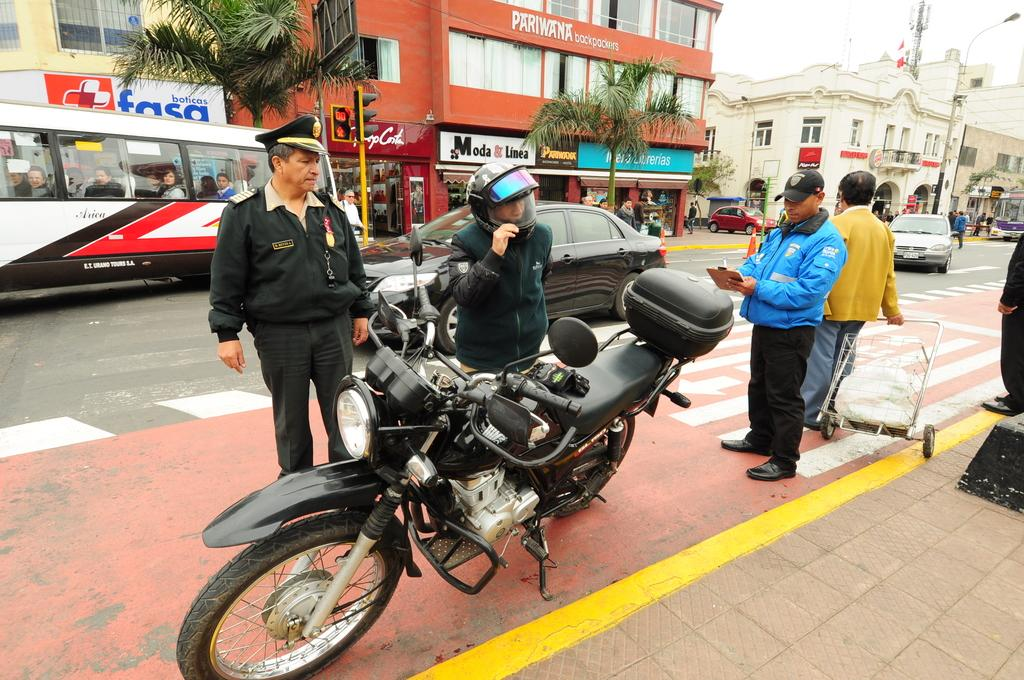What is the main object in the foreground of the image? There is a bike in the foreground of the image. What are the people in the image doing? The people are standing on the pavement. What can be seen in the background of the image? There are houses, trees, poles, and vehicles on the road in the background of the image. What type of brass instrument is being played by the bee in the image? There is no bee or brass instrument present in the image. Is there a club visible in the image? There is no club visible in the image. 